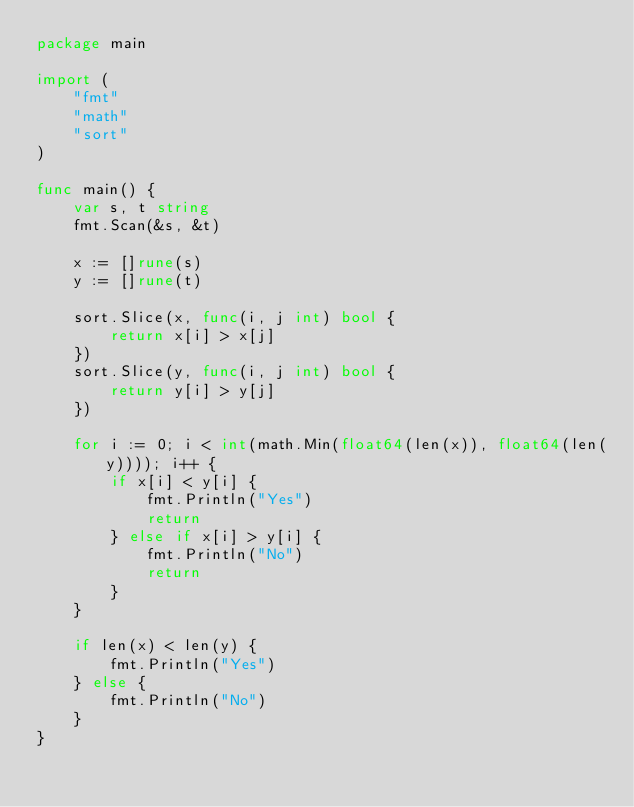Convert code to text. <code><loc_0><loc_0><loc_500><loc_500><_Go_>package main

import (
	"fmt"
	"math"
	"sort"
)

func main() {
	var s, t string
	fmt.Scan(&s, &t)

	x := []rune(s)
	y := []rune(t)

	sort.Slice(x, func(i, j int) bool {
		return x[i] > x[j]
	})
	sort.Slice(y, func(i, j int) bool {
		return y[i] > y[j]
	})

	for i := 0; i < int(math.Min(float64(len(x)), float64(len(y)))); i++ {
		if x[i] < y[i] {
			fmt.Println("Yes")
			return
		} else if x[i] > y[i] {
			fmt.Println("No")
			return
		}
	}

	if len(x) < len(y) {
		fmt.Println("Yes")
	} else {
		fmt.Println("No")
	}
}
</code> 